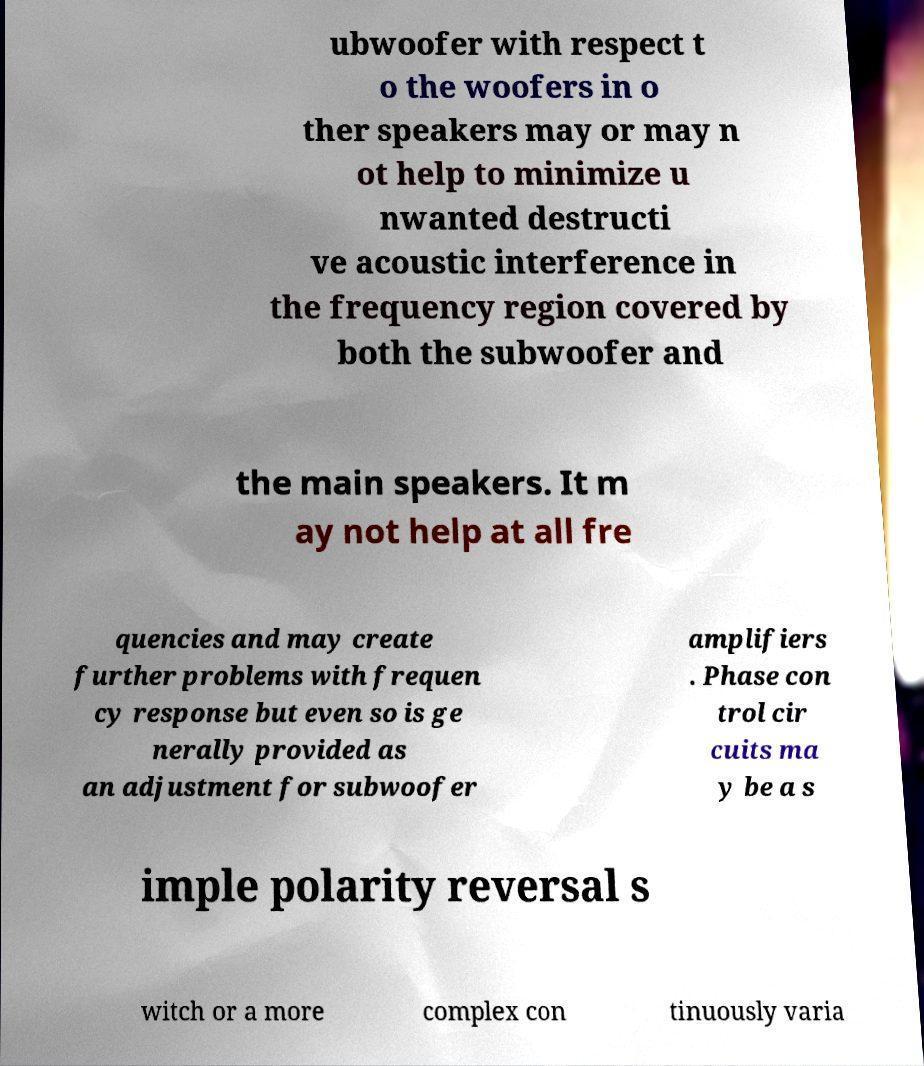Please identify and transcribe the text found in this image. ubwoofer with respect t o the woofers in o ther speakers may or may n ot help to minimize u nwanted destructi ve acoustic interference in the frequency region covered by both the subwoofer and the main speakers. It m ay not help at all fre quencies and may create further problems with frequen cy response but even so is ge nerally provided as an adjustment for subwoofer amplifiers . Phase con trol cir cuits ma y be a s imple polarity reversal s witch or a more complex con tinuously varia 